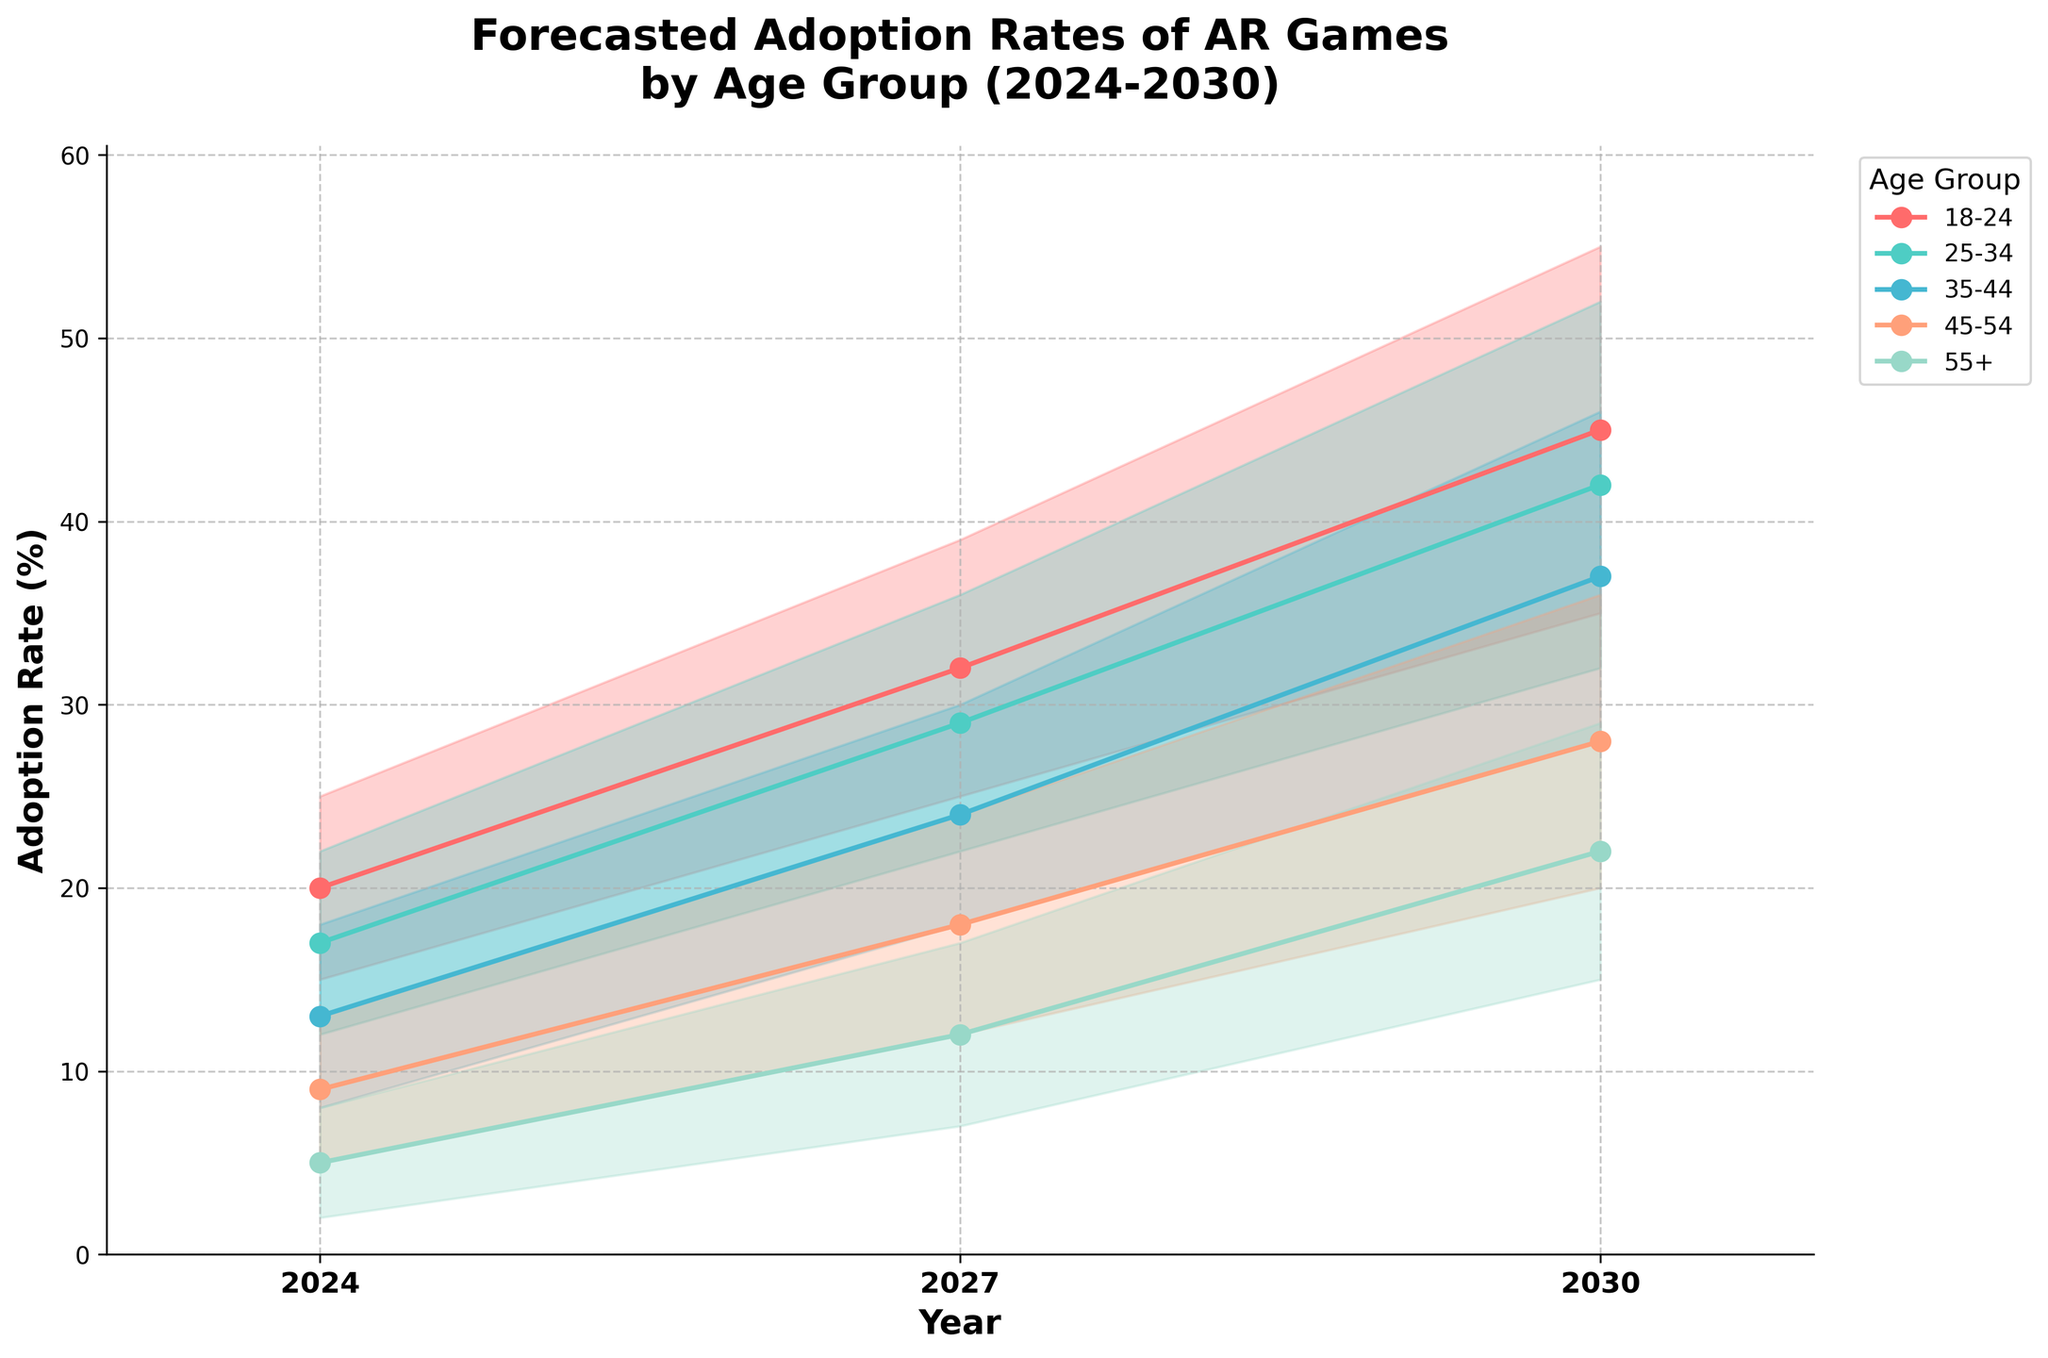What's the title of the chart? The title is displayed at the top of the chart, clearly indicating what it represents.
Answer: Forecasted Adoption Rates of AR Games by Age Group (2024-2030) What are the demographic groups in the chart? The demographic groups are listed in the legend on the right side of the chart.
Answer: 18-24, 25-34, 35-44, 45-54, 55+ Which year shows the highest adoption rate for the 18-24 age group? By looking at the plotted lines for the 18-24 age group and comparing the Mid_Estimate values, you can identify the highest point.
Answer: 2030 What is the mid-estimate adoption rate for the 25-34 age group in 2027? Find the intersection of the 25-34 age group's line with the year 2027. The mid-estimate value is labeled there.
Answer: 29% How do the adoption rates for the 35-44 and 45-54 age groups compare in 2030? Compare the mid-estimate values for both age groups in 2030 to see which is higher.
Answer: 35-44 age group has a higher adoption rate: 37% vs. 28% What is the average mid-estimate adoption rate across all age groups in 2024? Sum the mid-estimate values for all age groups in 2024 and divide by 5 (the number of age groups).  (20 + 17 + 13 + 9 + 5) / 5 = 64 / 5 = 12.8%
Answer: 12.8% What's the increase in the mid-estimate adoption rate for the 55+ age group from 2024 to 2030? Subtract the 2024 mid-estimate from the 2030 mid-estimate for the 55+ age group. 22% - 5% = 17%
Answer: 17% For which age group is the adoption rate expected to increase the most between 2024 and 2030? Calculate the difference in mid-estimates between 2024 and 2030 for each age group and identify the age group with the highest increase.
Answer: 18-24 age group Compare the range (high minus low estimate) of adoption rates for the 45-54 age group in 2024 and 2030. Which year has a wider range? Calculate the range for 2024 (13 - 5) and 2030 (36 - 20). 2030 has a wider range of 16 compared to 2024's range of 8.
Answer: 2030 